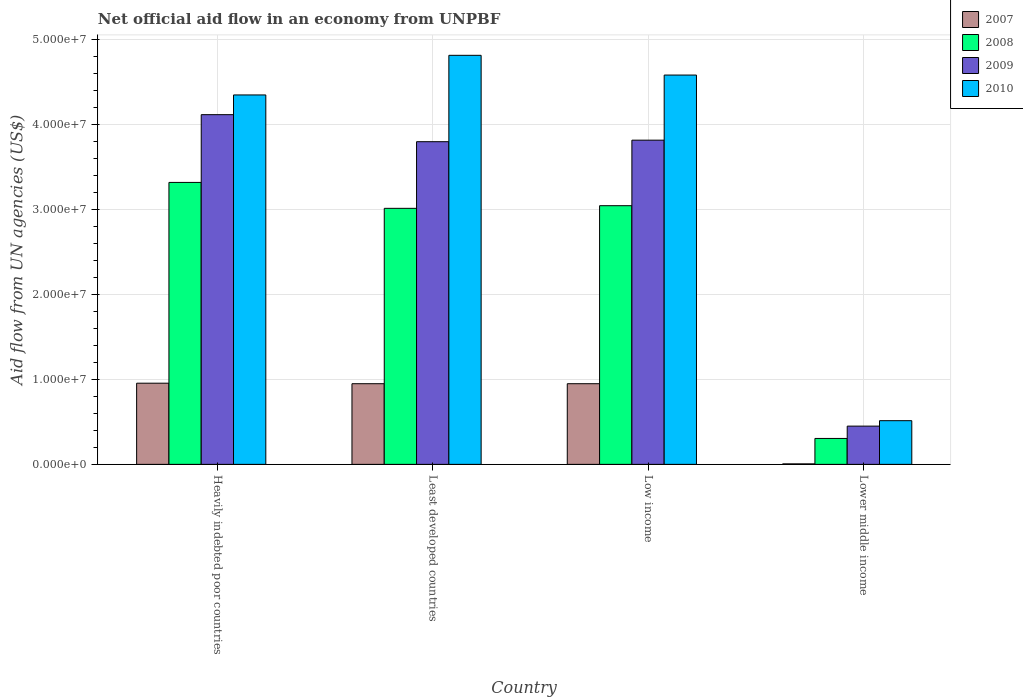Are the number of bars per tick equal to the number of legend labels?
Offer a terse response. Yes. Are the number of bars on each tick of the X-axis equal?
Provide a short and direct response. Yes. What is the label of the 3rd group of bars from the left?
Offer a very short reply. Low income. In how many cases, is the number of bars for a given country not equal to the number of legend labels?
Offer a very short reply. 0. What is the net official aid flow in 2010 in Heavily indebted poor countries?
Your answer should be very brief. 4.35e+07. Across all countries, what is the maximum net official aid flow in 2009?
Your answer should be compact. 4.11e+07. Across all countries, what is the minimum net official aid flow in 2008?
Your response must be concise. 3.05e+06. In which country was the net official aid flow in 2007 maximum?
Keep it short and to the point. Heavily indebted poor countries. In which country was the net official aid flow in 2007 minimum?
Your response must be concise. Lower middle income. What is the total net official aid flow in 2008 in the graph?
Provide a succinct answer. 9.68e+07. What is the difference between the net official aid flow in 2009 in Heavily indebted poor countries and that in Low income?
Give a very brief answer. 3.00e+06. What is the difference between the net official aid flow in 2009 in Lower middle income and the net official aid flow in 2007 in Low income?
Ensure brevity in your answer.  -4.99e+06. What is the average net official aid flow in 2008 per country?
Ensure brevity in your answer.  2.42e+07. What is the difference between the net official aid flow of/in 2007 and net official aid flow of/in 2009 in Lower middle income?
Your response must be concise. -4.44e+06. What is the ratio of the net official aid flow in 2007 in Low income to that in Lower middle income?
Your response must be concise. 158.17. Is the net official aid flow in 2007 in Least developed countries less than that in Lower middle income?
Provide a succinct answer. No. What is the difference between the highest and the second highest net official aid flow in 2009?
Offer a terse response. 3.18e+06. What is the difference between the highest and the lowest net official aid flow in 2007?
Offer a terse response. 9.49e+06. Is the sum of the net official aid flow in 2009 in Low income and Lower middle income greater than the maximum net official aid flow in 2010 across all countries?
Make the answer very short. No. Is it the case that in every country, the sum of the net official aid flow in 2010 and net official aid flow in 2007 is greater than the sum of net official aid flow in 2009 and net official aid flow in 2008?
Make the answer very short. No. Are all the bars in the graph horizontal?
Ensure brevity in your answer.  No. How many countries are there in the graph?
Your response must be concise. 4. What is the difference between two consecutive major ticks on the Y-axis?
Provide a succinct answer. 1.00e+07. Are the values on the major ticks of Y-axis written in scientific E-notation?
Keep it short and to the point. Yes. How many legend labels are there?
Offer a very short reply. 4. What is the title of the graph?
Provide a short and direct response. Net official aid flow in an economy from UNPBF. Does "2010" appear as one of the legend labels in the graph?
Keep it short and to the point. Yes. What is the label or title of the X-axis?
Your response must be concise. Country. What is the label or title of the Y-axis?
Make the answer very short. Aid flow from UN agencies (US$). What is the Aid flow from UN agencies (US$) in 2007 in Heavily indebted poor countries?
Keep it short and to the point. 9.55e+06. What is the Aid flow from UN agencies (US$) in 2008 in Heavily indebted poor countries?
Provide a succinct answer. 3.32e+07. What is the Aid flow from UN agencies (US$) of 2009 in Heavily indebted poor countries?
Give a very brief answer. 4.11e+07. What is the Aid flow from UN agencies (US$) of 2010 in Heavily indebted poor countries?
Offer a very short reply. 4.35e+07. What is the Aid flow from UN agencies (US$) of 2007 in Least developed countries?
Keep it short and to the point. 9.49e+06. What is the Aid flow from UN agencies (US$) of 2008 in Least developed countries?
Make the answer very short. 3.01e+07. What is the Aid flow from UN agencies (US$) of 2009 in Least developed countries?
Give a very brief answer. 3.80e+07. What is the Aid flow from UN agencies (US$) of 2010 in Least developed countries?
Your answer should be very brief. 4.81e+07. What is the Aid flow from UN agencies (US$) in 2007 in Low income?
Offer a terse response. 9.49e+06. What is the Aid flow from UN agencies (US$) in 2008 in Low income?
Make the answer very short. 3.04e+07. What is the Aid flow from UN agencies (US$) in 2009 in Low income?
Ensure brevity in your answer.  3.81e+07. What is the Aid flow from UN agencies (US$) in 2010 in Low income?
Keep it short and to the point. 4.58e+07. What is the Aid flow from UN agencies (US$) of 2008 in Lower middle income?
Give a very brief answer. 3.05e+06. What is the Aid flow from UN agencies (US$) of 2009 in Lower middle income?
Provide a succinct answer. 4.50e+06. What is the Aid flow from UN agencies (US$) of 2010 in Lower middle income?
Keep it short and to the point. 5.14e+06. Across all countries, what is the maximum Aid flow from UN agencies (US$) in 2007?
Provide a succinct answer. 9.55e+06. Across all countries, what is the maximum Aid flow from UN agencies (US$) in 2008?
Keep it short and to the point. 3.32e+07. Across all countries, what is the maximum Aid flow from UN agencies (US$) in 2009?
Provide a succinct answer. 4.11e+07. Across all countries, what is the maximum Aid flow from UN agencies (US$) in 2010?
Your answer should be very brief. 4.81e+07. Across all countries, what is the minimum Aid flow from UN agencies (US$) of 2007?
Your response must be concise. 6.00e+04. Across all countries, what is the minimum Aid flow from UN agencies (US$) of 2008?
Your answer should be very brief. 3.05e+06. Across all countries, what is the minimum Aid flow from UN agencies (US$) of 2009?
Make the answer very short. 4.50e+06. Across all countries, what is the minimum Aid flow from UN agencies (US$) of 2010?
Offer a terse response. 5.14e+06. What is the total Aid flow from UN agencies (US$) of 2007 in the graph?
Keep it short and to the point. 2.86e+07. What is the total Aid flow from UN agencies (US$) in 2008 in the graph?
Your answer should be very brief. 9.68e+07. What is the total Aid flow from UN agencies (US$) of 2009 in the graph?
Ensure brevity in your answer.  1.22e+08. What is the total Aid flow from UN agencies (US$) in 2010 in the graph?
Provide a short and direct response. 1.43e+08. What is the difference between the Aid flow from UN agencies (US$) in 2007 in Heavily indebted poor countries and that in Least developed countries?
Provide a succinct answer. 6.00e+04. What is the difference between the Aid flow from UN agencies (US$) in 2008 in Heavily indebted poor countries and that in Least developed countries?
Keep it short and to the point. 3.05e+06. What is the difference between the Aid flow from UN agencies (US$) of 2009 in Heavily indebted poor countries and that in Least developed countries?
Keep it short and to the point. 3.18e+06. What is the difference between the Aid flow from UN agencies (US$) of 2010 in Heavily indebted poor countries and that in Least developed countries?
Offer a very short reply. -4.66e+06. What is the difference between the Aid flow from UN agencies (US$) in 2007 in Heavily indebted poor countries and that in Low income?
Your response must be concise. 6.00e+04. What is the difference between the Aid flow from UN agencies (US$) in 2008 in Heavily indebted poor countries and that in Low income?
Give a very brief answer. 2.74e+06. What is the difference between the Aid flow from UN agencies (US$) of 2010 in Heavily indebted poor countries and that in Low income?
Make the answer very short. -2.34e+06. What is the difference between the Aid flow from UN agencies (US$) in 2007 in Heavily indebted poor countries and that in Lower middle income?
Provide a short and direct response. 9.49e+06. What is the difference between the Aid flow from UN agencies (US$) of 2008 in Heavily indebted poor countries and that in Lower middle income?
Your answer should be very brief. 3.01e+07. What is the difference between the Aid flow from UN agencies (US$) of 2009 in Heavily indebted poor countries and that in Lower middle income?
Offer a terse response. 3.66e+07. What is the difference between the Aid flow from UN agencies (US$) of 2010 in Heavily indebted poor countries and that in Lower middle income?
Make the answer very short. 3.83e+07. What is the difference between the Aid flow from UN agencies (US$) in 2008 in Least developed countries and that in Low income?
Make the answer very short. -3.10e+05. What is the difference between the Aid flow from UN agencies (US$) in 2010 in Least developed countries and that in Low income?
Your answer should be very brief. 2.32e+06. What is the difference between the Aid flow from UN agencies (US$) in 2007 in Least developed countries and that in Lower middle income?
Provide a short and direct response. 9.43e+06. What is the difference between the Aid flow from UN agencies (US$) in 2008 in Least developed countries and that in Lower middle income?
Your response must be concise. 2.71e+07. What is the difference between the Aid flow from UN agencies (US$) in 2009 in Least developed countries and that in Lower middle income?
Provide a succinct answer. 3.35e+07. What is the difference between the Aid flow from UN agencies (US$) in 2010 in Least developed countries and that in Lower middle income?
Give a very brief answer. 4.30e+07. What is the difference between the Aid flow from UN agencies (US$) of 2007 in Low income and that in Lower middle income?
Ensure brevity in your answer.  9.43e+06. What is the difference between the Aid flow from UN agencies (US$) of 2008 in Low income and that in Lower middle income?
Offer a terse response. 2.74e+07. What is the difference between the Aid flow from UN agencies (US$) of 2009 in Low income and that in Lower middle income?
Offer a very short reply. 3.36e+07. What is the difference between the Aid flow from UN agencies (US$) in 2010 in Low income and that in Lower middle income?
Your response must be concise. 4.07e+07. What is the difference between the Aid flow from UN agencies (US$) in 2007 in Heavily indebted poor countries and the Aid flow from UN agencies (US$) in 2008 in Least developed countries?
Your response must be concise. -2.06e+07. What is the difference between the Aid flow from UN agencies (US$) of 2007 in Heavily indebted poor countries and the Aid flow from UN agencies (US$) of 2009 in Least developed countries?
Make the answer very short. -2.84e+07. What is the difference between the Aid flow from UN agencies (US$) of 2007 in Heavily indebted poor countries and the Aid flow from UN agencies (US$) of 2010 in Least developed countries?
Make the answer very short. -3.86e+07. What is the difference between the Aid flow from UN agencies (US$) in 2008 in Heavily indebted poor countries and the Aid flow from UN agencies (US$) in 2009 in Least developed countries?
Give a very brief answer. -4.79e+06. What is the difference between the Aid flow from UN agencies (US$) in 2008 in Heavily indebted poor countries and the Aid flow from UN agencies (US$) in 2010 in Least developed countries?
Your answer should be compact. -1.50e+07. What is the difference between the Aid flow from UN agencies (US$) of 2009 in Heavily indebted poor countries and the Aid flow from UN agencies (US$) of 2010 in Least developed countries?
Keep it short and to the point. -6.98e+06. What is the difference between the Aid flow from UN agencies (US$) of 2007 in Heavily indebted poor countries and the Aid flow from UN agencies (US$) of 2008 in Low income?
Provide a succinct answer. -2.09e+07. What is the difference between the Aid flow from UN agencies (US$) in 2007 in Heavily indebted poor countries and the Aid flow from UN agencies (US$) in 2009 in Low income?
Your answer should be compact. -2.86e+07. What is the difference between the Aid flow from UN agencies (US$) in 2007 in Heavily indebted poor countries and the Aid flow from UN agencies (US$) in 2010 in Low income?
Keep it short and to the point. -3.62e+07. What is the difference between the Aid flow from UN agencies (US$) in 2008 in Heavily indebted poor countries and the Aid flow from UN agencies (US$) in 2009 in Low income?
Provide a succinct answer. -4.97e+06. What is the difference between the Aid flow from UN agencies (US$) in 2008 in Heavily indebted poor countries and the Aid flow from UN agencies (US$) in 2010 in Low income?
Your answer should be compact. -1.26e+07. What is the difference between the Aid flow from UN agencies (US$) of 2009 in Heavily indebted poor countries and the Aid flow from UN agencies (US$) of 2010 in Low income?
Provide a short and direct response. -4.66e+06. What is the difference between the Aid flow from UN agencies (US$) in 2007 in Heavily indebted poor countries and the Aid flow from UN agencies (US$) in 2008 in Lower middle income?
Give a very brief answer. 6.50e+06. What is the difference between the Aid flow from UN agencies (US$) in 2007 in Heavily indebted poor countries and the Aid flow from UN agencies (US$) in 2009 in Lower middle income?
Offer a terse response. 5.05e+06. What is the difference between the Aid flow from UN agencies (US$) in 2007 in Heavily indebted poor countries and the Aid flow from UN agencies (US$) in 2010 in Lower middle income?
Your answer should be very brief. 4.41e+06. What is the difference between the Aid flow from UN agencies (US$) in 2008 in Heavily indebted poor countries and the Aid flow from UN agencies (US$) in 2009 in Lower middle income?
Your response must be concise. 2.87e+07. What is the difference between the Aid flow from UN agencies (US$) of 2008 in Heavily indebted poor countries and the Aid flow from UN agencies (US$) of 2010 in Lower middle income?
Your answer should be very brief. 2.80e+07. What is the difference between the Aid flow from UN agencies (US$) in 2009 in Heavily indebted poor countries and the Aid flow from UN agencies (US$) in 2010 in Lower middle income?
Ensure brevity in your answer.  3.60e+07. What is the difference between the Aid flow from UN agencies (US$) of 2007 in Least developed countries and the Aid flow from UN agencies (US$) of 2008 in Low income?
Ensure brevity in your answer.  -2.09e+07. What is the difference between the Aid flow from UN agencies (US$) in 2007 in Least developed countries and the Aid flow from UN agencies (US$) in 2009 in Low income?
Make the answer very short. -2.86e+07. What is the difference between the Aid flow from UN agencies (US$) of 2007 in Least developed countries and the Aid flow from UN agencies (US$) of 2010 in Low income?
Offer a terse response. -3.63e+07. What is the difference between the Aid flow from UN agencies (US$) of 2008 in Least developed countries and the Aid flow from UN agencies (US$) of 2009 in Low income?
Give a very brief answer. -8.02e+06. What is the difference between the Aid flow from UN agencies (US$) of 2008 in Least developed countries and the Aid flow from UN agencies (US$) of 2010 in Low income?
Provide a short and direct response. -1.57e+07. What is the difference between the Aid flow from UN agencies (US$) of 2009 in Least developed countries and the Aid flow from UN agencies (US$) of 2010 in Low income?
Your response must be concise. -7.84e+06. What is the difference between the Aid flow from UN agencies (US$) of 2007 in Least developed countries and the Aid flow from UN agencies (US$) of 2008 in Lower middle income?
Provide a short and direct response. 6.44e+06. What is the difference between the Aid flow from UN agencies (US$) of 2007 in Least developed countries and the Aid flow from UN agencies (US$) of 2009 in Lower middle income?
Offer a terse response. 4.99e+06. What is the difference between the Aid flow from UN agencies (US$) of 2007 in Least developed countries and the Aid flow from UN agencies (US$) of 2010 in Lower middle income?
Your answer should be compact. 4.35e+06. What is the difference between the Aid flow from UN agencies (US$) in 2008 in Least developed countries and the Aid flow from UN agencies (US$) in 2009 in Lower middle income?
Provide a short and direct response. 2.56e+07. What is the difference between the Aid flow from UN agencies (US$) in 2008 in Least developed countries and the Aid flow from UN agencies (US$) in 2010 in Lower middle income?
Ensure brevity in your answer.  2.50e+07. What is the difference between the Aid flow from UN agencies (US$) in 2009 in Least developed countries and the Aid flow from UN agencies (US$) in 2010 in Lower middle income?
Ensure brevity in your answer.  3.28e+07. What is the difference between the Aid flow from UN agencies (US$) of 2007 in Low income and the Aid flow from UN agencies (US$) of 2008 in Lower middle income?
Keep it short and to the point. 6.44e+06. What is the difference between the Aid flow from UN agencies (US$) in 2007 in Low income and the Aid flow from UN agencies (US$) in 2009 in Lower middle income?
Provide a succinct answer. 4.99e+06. What is the difference between the Aid flow from UN agencies (US$) in 2007 in Low income and the Aid flow from UN agencies (US$) in 2010 in Lower middle income?
Your answer should be compact. 4.35e+06. What is the difference between the Aid flow from UN agencies (US$) in 2008 in Low income and the Aid flow from UN agencies (US$) in 2009 in Lower middle income?
Your answer should be very brief. 2.59e+07. What is the difference between the Aid flow from UN agencies (US$) of 2008 in Low income and the Aid flow from UN agencies (US$) of 2010 in Lower middle income?
Offer a very short reply. 2.53e+07. What is the difference between the Aid flow from UN agencies (US$) in 2009 in Low income and the Aid flow from UN agencies (US$) in 2010 in Lower middle income?
Provide a succinct answer. 3.30e+07. What is the average Aid flow from UN agencies (US$) in 2007 per country?
Offer a terse response. 7.15e+06. What is the average Aid flow from UN agencies (US$) of 2008 per country?
Your answer should be very brief. 2.42e+07. What is the average Aid flow from UN agencies (US$) in 2009 per country?
Provide a succinct answer. 3.04e+07. What is the average Aid flow from UN agencies (US$) in 2010 per country?
Ensure brevity in your answer.  3.56e+07. What is the difference between the Aid flow from UN agencies (US$) of 2007 and Aid flow from UN agencies (US$) of 2008 in Heavily indebted poor countries?
Your answer should be very brief. -2.36e+07. What is the difference between the Aid flow from UN agencies (US$) of 2007 and Aid flow from UN agencies (US$) of 2009 in Heavily indebted poor countries?
Your response must be concise. -3.16e+07. What is the difference between the Aid flow from UN agencies (US$) of 2007 and Aid flow from UN agencies (US$) of 2010 in Heavily indebted poor countries?
Keep it short and to the point. -3.39e+07. What is the difference between the Aid flow from UN agencies (US$) in 2008 and Aid flow from UN agencies (US$) in 2009 in Heavily indebted poor countries?
Your answer should be compact. -7.97e+06. What is the difference between the Aid flow from UN agencies (US$) in 2008 and Aid flow from UN agencies (US$) in 2010 in Heavily indebted poor countries?
Make the answer very short. -1.03e+07. What is the difference between the Aid flow from UN agencies (US$) in 2009 and Aid flow from UN agencies (US$) in 2010 in Heavily indebted poor countries?
Provide a succinct answer. -2.32e+06. What is the difference between the Aid flow from UN agencies (US$) in 2007 and Aid flow from UN agencies (US$) in 2008 in Least developed countries?
Give a very brief answer. -2.06e+07. What is the difference between the Aid flow from UN agencies (US$) of 2007 and Aid flow from UN agencies (US$) of 2009 in Least developed countries?
Your answer should be compact. -2.85e+07. What is the difference between the Aid flow from UN agencies (US$) of 2007 and Aid flow from UN agencies (US$) of 2010 in Least developed countries?
Offer a very short reply. -3.86e+07. What is the difference between the Aid flow from UN agencies (US$) in 2008 and Aid flow from UN agencies (US$) in 2009 in Least developed countries?
Provide a short and direct response. -7.84e+06. What is the difference between the Aid flow from UN agencies (US$) in 2008 and Aid flow from UN agencies (US$) in 2010 in Least developed countries?
Make the answer very short. -1.80e+07. What is the difference between the Aid flow from UN agencies (US$) of 2009 and Aid flow from UN agencies (US$) of 2010 in Least developed countries?
Offer a very short reply. -1.02e+07. What is the difference between the Aid flow from UN agencies (US$) of 2007 and Aid flow from UN agencies (US$) of 2008 in Low income?
Offer a terse response. -2.09e+07. What is the difference between the Aid flow from UN agencies (US$) of 2007 and Aid flow from UN agencies (US$) of 2009 in Low income?
Give a very brief answer. -2.86e+07. What is the difference between the Aid flow from UN agencies (US$) in 2007 and Aid flow from UN agencies (US$) in 2010 in Low income?
Your answer should be very brief. -3.63e+07. What is the difference between the Aid flow from UN agencies (US$) of 2008 and Aid flow from UN agencies (US$) of 2009 in Low income?
Offer a very short reply. -7.71e+06. What is the difference between the Aid flow from UN agencies (US$) in 2008 and Aid flow from UN agencies (US$) in 2010 in Low income?
Ensure brevity in your answer.  -1.54e+07. What is the difference between the Aid flow from UN agencies (US$) of 2009 and Aid flow from UN agencies (US$) of 2010 in Low income?
Give a very brief answer. -7.66e+06. What is the difference between the Aid flow from UN agencies (US$) of 2007 and Aid flow from UN agencies (US$) of 2008 in Lower middle income?
Provide a short and direct response. -2.99e+06. What is the difference between the Aid flow from UN agencies (US$) in 2007 and Aid flow from UN agencies (US$) in 2009 in Lower middle income?
Keep it short and to the point. -4.44e+06. What is the difference between the Aid flow from UN agencies (US$) in 2007 and Aid flow from UN agencies (US$) in 2010 in Lower middle income?
Offer a terse response. -5.08e+06. What is the difference between the Aid flow from UN agencies (US$) of 2008 and Aid flow from UN agencies (US$) of 2009 in Lower middle income?
Provide a succinct answer. -1.45e+06. What is the difference between the Aid flow from UN agencies (US$) of 2008 and Aid flow from UN agencies (US$) of 2010 in Lower middle income?
Offer a very short reply. -2.09e+06. What is the difference between the Aid flow from UN agencies (US$) in 2009 and Aid flow from UN agencies (US$) in 2010 in Lower middle income?
Give a very brief answer. -6.40e+05. What is the ratio of the Aid flow from UN agencies (US$) of 2007 in Heavily indebted poor countries to that in Least developed countries?
Your response must be concise. 1.01. What is the ratio of the Aid flow from UN agencies (US$) in 2008 in Heavily indebted poor countries to that in Least developed countries?
Keep it short and to the point. 1.1. What is the ratio of the Aid flow from UN agencies (US$) of 2009 in Heavily indebted poor countries to that in Least developed countries?
Your answer should be compact. 1.08. What is the ratio of the Aid flow from UN agencies (US$) in 2010 in Heavily indebted poor countries to that in Least developed countries?
Give a very brief answer. 0.9. What is the ratio of the Aid flow from UN agencies (US$) in 2008 in Heavily indebted poor countries to that in Low income?
Provide a succinct answer. 1.09. What is the ratio of the Aid flow from UN agencies (US$) of 2009 in Heavily indebted poor countries to that in Low income?
Give a very brief answer. 1.08. What is the ratio of the Aid flow from UN agencies (US$) in 2010 in Heavily indebted poor countries to that in Low income?
Offer a terse response. 0.95. What is the ratio of the Aid flow from UN agencies (US$) in 2007 in Heavily indebted poor countries to that in Lower middle income?
Your answer should be very brief. 159.17. What is the ratio of the Aid flow from UN agencies (US$) in 2008 in Heavily indebted poor countries to that in Lower middle income?
Offer a terse response. 10.88. What is the ratio of the Aid flow from UN agencies (US$) in 2009 in Heavily indebted poor countries to that in Lower middle income?
Provide a succinct answer. 9.14. What is the ratio of the Aid flow from UN agencies (US$) in 2010 in Heavily indebted poor countries to that in Lower middle income?
Provide a succinct answer. 8.46. What is the ratio of the Aid flow from UN agencies (US$) in 2007 in Least developed countries to that in Low income?
Provide a succinct answer. 1. What is the ratio of the Aid flow from UN agencies (US$) of 2008 in Least developed countries to that in Low income?
Provide a succinct answer. 0.99. What is the ratio of the Aid flow from UN agencies (US$) of 2010 in Least developed countries to that in Low income?
Ensure brevity in your answer.  1.05. What is the ratio of the Aid flow from UN agencies (US$) in 2007 in Least developed countries to that in Lower middle income?
Your answer should be very brief. 158.17. What is the ratio of the Aid flow from UN agencies (US$) in 2008 in Least developed countries to that in Lower middle income?
Your answer should be compact. 9.88. What is the ratio of the Aid flow from UN agencies (US$) in 2009 in Least developed countries to that in Lower middle income?
Keep it short and to the point. 8.44. What is the ratio of the Aid flow from UN agencies (US$) in 2010 in Least developed countries to that in Lower middle income?
Give a very brief answer. 9.36. What is the ratio of the Aid flow from UN agencies (US$) in 2007 in Low income to that in Lower middle income?
Ensure brevity in your answer.  158.17. What is the ratio of the Aid flow from UN agencies (US$) of 2008 in Low income to that in Lower middle income?
Make the answer very short. 9.98. What is the ratio of the Aid flow from UN agencies (US$) in 2009 in Low income to that in Lower middle income?
Provide a short and direct response. 8.48. What is the ratio of the Aid flow from UN agencies (US$) in 2010 in Low income to that in Lower middle income?
Make the answer very short. 8.91. What is the difference between the highest and the second highest Aid flow from UN agencies (US$) in 2008?
Offer a terse response. 2.74e+06. What is the difference between the highest and the second highest Aid flow from UN agencies (US$) of 2009?
Offer a very short reply. 3.00e+06. What is the difference between the highest and the second highest Aid flow from UN agencies (US$) of 2010?
Ensure brevity in your answer.  2.32e+06. What is the difference between the highest and the lowest Aid flow from UN agencies (US$) of 2007?
Your answer should be very brief. 9.49e+06. What is the difference between the highest and the lowest Aid flow from UN agencies (US$) in 2008?
Make the answer very short. 3.01e+07. What is the difference between the highest and the lowest Aid flow from UN agencies (US$) in 2009?
Your answer should be very brief. 3.66e+07. What is the difference between the highest and the lowest Aid flow from UN agencies (US$) in 2010?
Your answer should be compact. 4.30e+07. 